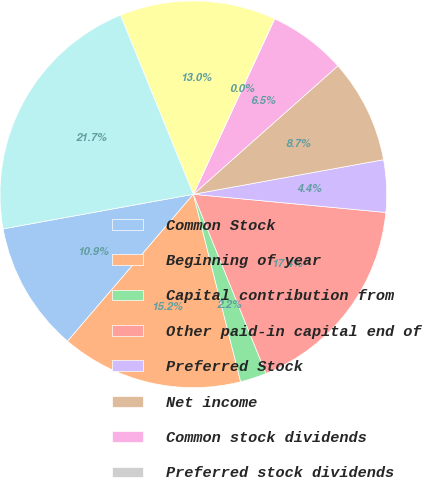Convert chart to OTSL. <chart><loc_0><loc_0><loc_500><loc_500><pie_chart><fcel>Common Stock<fcel>Beginning of year<fcel>Capital contribution from<fcel>Other paid-in capital end of<fcel>Preferred Stock<fcel>Net income<fcel>Common stock dividends<fcel>Preferred stock dividends<fcel>Retained earnings end of year<fcel>Total Shareholders' Equity<nl><fcel>10.87%<fcel>15.21%<fcel>2.19%<fcel>17.38%<fcel>4.36%<fcel>8.7%<fcel>6.53%<fcel>0.02%<fcel>13.04%<fcel>21.72%<nl></chart> 